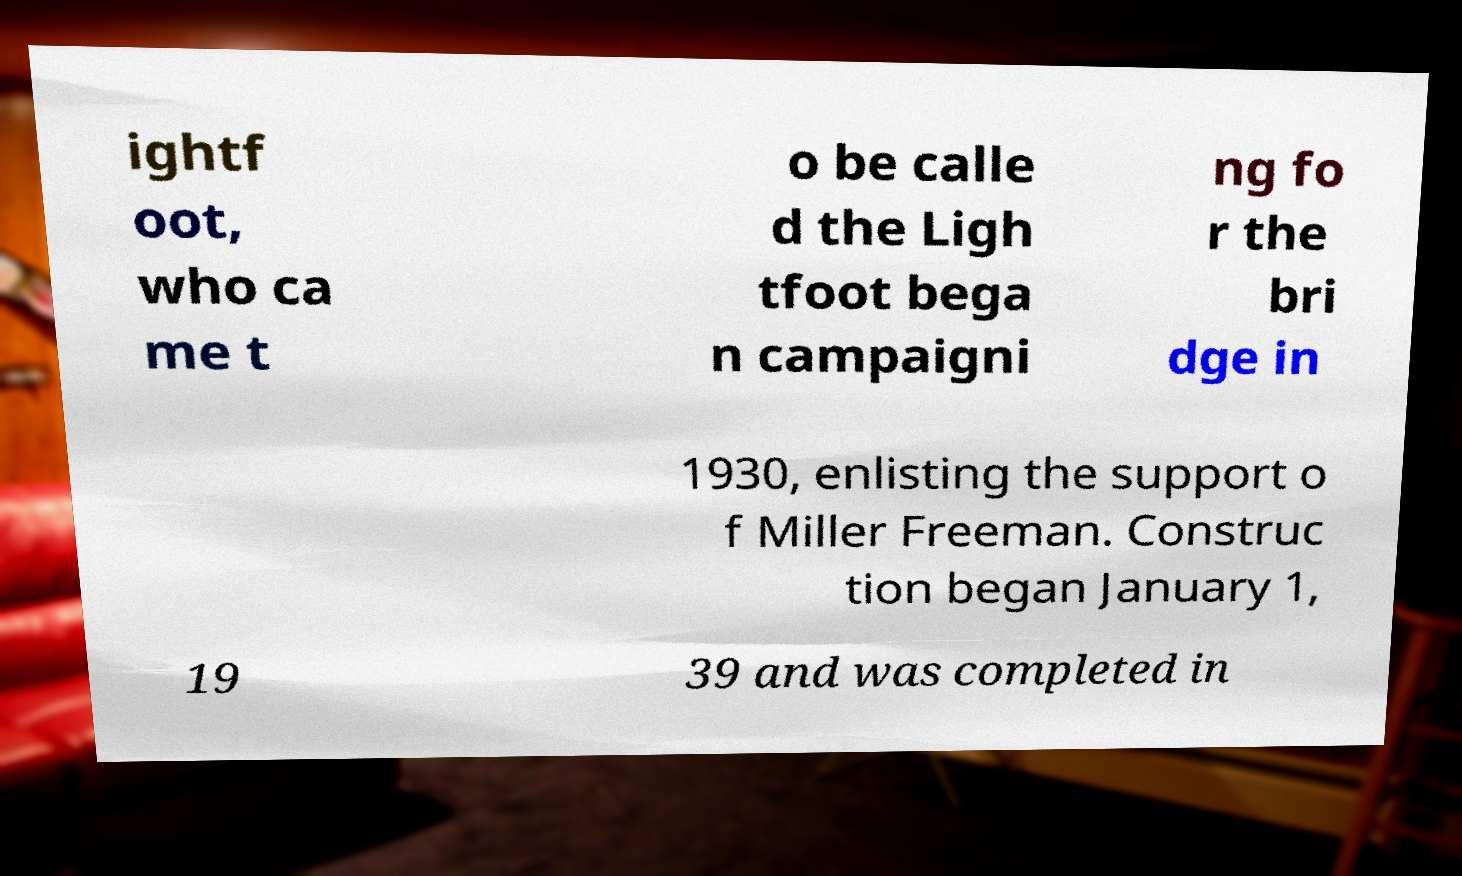There's text embedded in this image that I need extracted. Can you transcribe it verbatim? ightf oot, who ca me t o be calle d the Ligh tfoot bega n campaigni ng fo r the bri dge in 1930, enlisting the support o f Miller Freeman. Construc tion began January 1, 19 39 and was completed in 